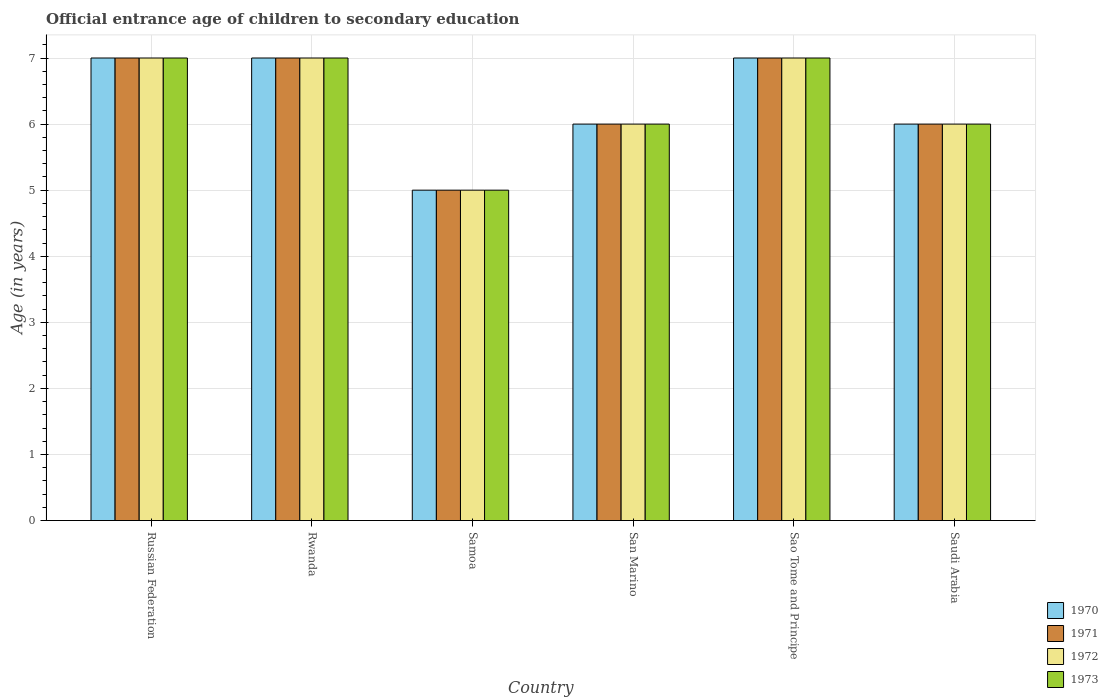What is the label of the 2nd group of bars from the left?
Your answer should be compact. Rwanda. In how many cases, is the number of bars for a given country not equal to the number of legend labels?
Provide a succinct answer. 0. Across all countries, what is the minimum secondary school starting age of children in 1971?
Provide a succinct answer. 5. In which country was the secondary school starting age of children in 1972 maximum?
Give a very brief answer. Russian Federation. In which country was the secondary school starting age of children in 1970 minimum?
Offer a terse response. Samoa. What is the total secondary school starting age of children in 1971 in the graph?
Keep it short and to the point. 38. What is the average secondary school starting age of children in 1972 per country?
Give a very brief answer. 6.33. What is the difference between the secondary school starting age of children of/in 1973 and secondary school starting age of children of/in 1970 in Russian Federation?
Your answer should be compact. 0. In how many countries, is the secondary school starting age of children in 1972 greater than 1.8 years?
Your answer should be compact. 6. What is the ratio of the secondary school starting age of children in 1971 in Sao Tome and Principe to that in Saudi Arabia?
Keep it short and to the point. 1.17. Is the secondary school starting age of children in 1973 in Rwanda less than that in Saudi Arabia?
Keep it short and to the point. No. What is the difference between the highest and the lowest secondary school starting age of children in 1972?
Provide a short and direct response. 2. What does the 1st bar from the right in Sao Tome and Principe represents?
Your answer should be compact. 1973. Is it the case that in every country, the sum of the secondary school starting age of children in 1972 and secondary school starting age of children in 1970 is greater than the secondary school starting age of children in 1971?
Keep it short and to the point. Yes. How many bars are there?
Keep it short and to the point. 24. What is the difference between two consecutive major ticks on the Y-axis?
Keep it short and to the point. 1. Are the values on the major ticks of Y-axis written in scientific E-notation?
Give a very brief answer. No. How are the legend labels stacked?
Your answer should be compact. Vertical. What is the title of the graph?
Give a very brief answer. Official entrance age of children to secondary education. What is the label or title of the X-axis?
Offer a very short reply. Country. What is the label or title of the Y-axis?
Offer a terse response. Age (in years). What is the Age (in years) of 1971 in Russian Federation?
Provide a succinct answer. 7. What is the Age (in years) of 1972 in Russian Federation?
Your answer should be very brief. 7. What is the Age (in years) in 1972 in Rwanda?
Provide a short and direct response. 7. What is the Age (in years) in 1971 in Samoa?
Offer a very short reply. 5. What is the Age (in years) in 1970 in San Marino?
Give a very brief answer. 6. What is the Age (in years) in 1971 in Sao Tome and Principe?
Your answer should be very brief. 7. What is the Age (in years) in 1972 in Sao Tome and Principe?
Your response must be concise. 7. What is the Age (in years) in 1973 in Sao Tome and Principe?
Provide a short and direct response. 7. What is the Age (in years) in 1971 in Saudi Arabia?
Make the answer very short. 6. What is the Age (in years) of 1972 in Saudi Arabia?
Your answer should be compact. 6. Across all countries, what is the maximum Age (in years) of 1970?
Give a very brief answer. 7. Across all countries, what is the maximum Age (in years) in 1971?
Offer a terse response. 7. Across all countries, what is the maximum Age (in years) in 1973?
Provide a short and direct response. 7. Across all countries, what is the minimum Age (in years) in 1970?
Your response must be concise. 5. Across all countries, what is the minimum Age (in years) in 1971?
Ensure brevity in your answer.  5. Across all countries, what is the minimum Age (in years) in 1973?
Offer a terse response. 5. What is the total Age (in years) in 1971 in the graph?
Offer a terse response. 38. What is the total Age (in years) in 1973 in the graph?
Provide a succinct answer. 38. What is the difference between the Age (in years) of 1972 in Russian Federation and that in Samoa?
Your answer should be compact. 2. What is the difference between the Age (in years) in 1973 in Russian Federation and that in Samoa?
Your response must be concise. 2. What is the difference between the Age (in years) in 1971 in Russian Federation and that in San Marino?
Give a very brief answer. 1. What is the difference between the Age (in years) in 1971 in Russian Federation and that in Sao Tome and Principe?
Keep it short and to the point. 0. What is the difference between the Age (in years) in 1972 in Russian Federation and that in Sao Tome and Principe?
Make the answer very short. 0. What is the difference between the Age (in years) in 1973 in Russian Federation and that in Sao Tome and Principe?
Provide a succinct answer. 0. What is the difference between the Age (in years) of 1972 in Russian Federation and that in Saudi Arabia?
Your answer should be compact. 1. What is the difference between the Age (in years) of 1970 in Rwanda and that in Samoa?
Your response must be concise. 2. What is the difference between the Age (in years) in 1970 in Rwanda and that in San Marino?
Ensure brevity in your answer.  1. What is the difference between the Age (in years) of 1972 in Rwanda and that in San Marino?
Your answer should be compact. 1. What is the difference between the Age (in years) in 1970 in Rwanda and that in Sao Tome and Principe?
Keep it short and to the point. 0. What is the difference between the Age (in years) in 1971 in Rwanda and that in Sao Tome and Principe?
Offer a terse response. 0. What is the difference between the Age (in years) of 1971 in Rwanda and that in Saudi Arabia?
Offer a very short reply. 1. What is the difference between the Age (in years) in 1971 in Samoa and that in San Marino?
Make the answer very short. -1. What is the difference between the Age (in years) in 1971 in Samoa and that in Sao Tome and Principe?
Keep it short and to the point. -2. What is the difference between the Age (in years) in 1973 in Samoa and that in Sao Tome and Principe?
Ensure brevity in your answer.  -2. What is the difference between the Age (in years) in 1970 in Samoa and that in Saudi Arabia?
Offer a terse response. -1. What is the difference between the Age (in years) in 1971 in Samoa and that in Saudi Arabia?
Offer a terse response. -1. What is the difference between the Age (in years) in 1973 in Samoa and that in Saudi Arabia?
Offer a very short reply. -1. What is the difference between the Age (in years) in 1970 in San Marino and that in Sao Tome and Principe?
Provide a succinct answer. -1. What is the difference between the Age (in years) of 1973 in San Marino and that in Sao Tome and Principe?
Your answer should be compact. -1. What is the difference between the Age (in years) in 1970 in San Marino and that in Saudi Arabia?
Your answer should be very brief. 0. What is the difference between the Age (in years) of 1971 in San Marino and that in Saudi Arabia?
Ensure brevity in your answer.  0. What is the difference between the Age (in years) of 1972 in San Marino and that in Saudi Arabia?
Keep it short and to the point. 0. What is the difference between the Age (in years) of 1973 in San Marino and that in Saudi Arabia?
Keep it short and to the point. 0. What is the difference between the Age (in years) in 1970 in Sao Tome and Principe and that in Saudi Arabia?
Provide a succinct answer. 1. What is the difference between the Age (in years) of 1972 in Sao Tome and Principe and that in Saudi Arabia?
Provide a short and direct response. 1. What is the difference between the Age (in years) of 1973 in Sao Tome and Principe and that in Saudi Arabia?
Give a very brief answer. 1. What is the difference between the Age (in years) in 1971 in Russian Federation and the Age (in years) in 1973 in Rwanda?
Your answer should be compact. 0. What is the difference between the Age (in years) in 1970 in Russian Federation and the Age (in years) in 1971 in Samoa?
Offer a very short reply. 2. What is the difference between the Age (in years) of 1970 in Russian Federation and the Age (in years) of 1972 in Samoa?
Provide a succinct answer. 2. What is the difference between the Age (in years) of 1970 in Russian Federation and the Age (in years) of 1973 in Samoa?
Make the answer very short. 2. What is the difference between the Age (in years) of 1971 in Russian Federation and the Age (in years) of 1972 in Samoa?
Provide a succinct answer. 2. What is the difference between the Age (in years) in 1971 in Russian Federation and the Age (in years) in 1973 in Samoa?
Give a very brief answer. 2. What is the difference between the Age (in years) of 1972 in Russian Federation and the Age (in years) of 1973 in Samoa?
Keep it short and to the point. 2. What is the difference between the Age (in years) in 1970 in Russian Federation and the Age (in years) in 1972 in San Marino?
Keep it short and to the point. 1. What is the difference between the Age (in years) of 1970 in Russian Federation and the Age (in years) of 1972 in Sao Tome and Principe?
Offer a terse response. 0. What is the difference between the Age (in years) of 1970 in Russian Federation and the Age (in years) of 1973 in Sao Tome and Principe?
Ensure brevity in your answer.  0. What is the difference between the Age (in years) of 1971 in Russian Federation and the Age (in years) of 1972 in Sao Tome and Principe?
Offer a very short reply. 0. What is the difference between the Age (in years) in 1972 in Russian Federation and the Age (in years) in 1973 in Sao Tome and Principe?
Give a very brief answer. 0. What is the difference between the Age (in years) of 1970 in Russian Federation and the Age (in years) of 1971 in Saudi Arabia?
Offer a terse response. 1. What is the difference between the Age (in years) of 1970 in Russian Federation and the Age (in years) of 1972 in Saudi Arabia?
Offer a very short reply. 1. What is the difference between the Age (in years) in 1972 in Russian Federation and the Age (in years) in 1973 in Saudi Arabia?
Give a very brief answer. 1. What is the difference between the Age (in years) of 1970 in Rwanda and the Age (in years) of 1973 in Samoa?
Ensure brevity in your answer.  2. What is the difference between the Age (in years) in 1971 in Rwanda and the Age (in years) in 1972 in Samoa?
Ensure brevity in your answer.  2. What is the difference between the Age (in years) of 1972 in Rwanda and the Age (in years) of 1973 in Samoa?
Offer a very short reply. 2. What is the difference between the Age (in years) in 1970 in Rwanda and the Age (in years) in 1971 in San Marino?
Ensure brevity in your answer.  1. What is the difference between the Age (in years) of 1970 in Rwanda and the Age (in years) of 1972 in San Marino?
Provide a short and direct response. 1. What is the difference between the Age (in years) of 1972 in Rwanda and the Age (in years) of 1973 in San Marino?
Keep it short and to the point. 1. What is the difference between the Age (in years) of 1970 in Rwanda and the Age (in years) of 1971 in Sao Tome and Principe?
Your answer should be very brief. 0. What is the difference between the Age (in years) of 1970 in Rwanda and the Age (in years) of 1973 in Sao Tome and Principe?
Ensure brevity in your answer.  0. What is the difference between the Age (in years) of 1971 in Rwanda and the Age (in years) of 1972 in Sao Tome and Principe?
Give a very brief answer. 0. What is the difference between the Age (in years) in 1970 in Rwanda and the Age (in years) in 1972 in Saudi Arabia?
Give a very brief answer. 1. What is the difference between the Age (in years) in 1970 in Rwanda and the Age (in years) in 1973 in Saudi Arabia?
Your answer should be very brief. 1. What is the difference between the Age (in years) of 1971 in Rwanda and the Age (in years) of 1972 in Saudi Arabia?
Give a very brief answer. 1. What is the difference between the Age (in years) in 1970 in Samoa and the Age (in years) in 1971 in San Marino?
Ensure brevity in your answer.  -1. What is the difference between the Age (in years) of 1970 in Samoa and the Age (in years) of 1972 in San Marino?
Keep it short and to the point. -1. What is the difference between the Age (in years) in 1971 in Samoa and the Age (in years) in 1973 in San Marino?
Provide a succinct answer. -1. What is the difference between the Age (in years) in 1972 in Samoa and the Age (in years) in 1973 in San Marino?
Give a very brief answer. -1. What is the difference between the Age (in years) of 1970 in Samoa and the Age (in years) of 1972 in Sao Tome and Principe?
Give a very brief answer. -2. What is the difference between the Age (in years) in 1970 in Samoa and the Age (in years) in 1973 in Sao Tome and Principe?
Ensure brevity in your answer.  -2. What is the difference between the Age (in years) in 1971 in Samoa and the Age (in years) in 1972 in Sao Tome and Principe?
Ensure brevity in your answer.  -2. What is the difference between the Age (in years) in 1970 in San Marino and the Age (in years) in 1971 in Sao Tome and Principe?
Offer a terse response. -1. What is the difference between the Age (in years) in 1970 in San Marino and the Age (in years) in 1973 in Sao Tome and Principe?
Provide a succinct answer. -1. What is the difference between the Age (in years) of 1971 in San Marino and the Age (in years) of 1972 in Sao Tome and Principe?
Give a very brief answer. -1. What is the difference between the Age (in years) in 1970 in San Marino and the Age (in years) in 1971 in Saudi Arabia?
Ensure brevity in your answer.  0. What is the difference between the Age (in years) of 1970 in San Marino and the Age (in years) of 1972 in Saudi Arabia?
Ensure brevity in your answer.  0. What is the difference between the Age (in years) in 1971 in San Marino and the Age (in years) in 1972 in Saudi Arabia?
Keep it short and to the point. 0. What is the difference between the Age (in years) in 1971 in San Marino and the Age (in years) in 1973 in Saudi Arabia?
Your answer should be very brief. 0. What is the difference between the Age (in years) in 1972 in San Marino and the Age (in years) in 1973 in Saudi Arabia?
Make the answer very short. 0. What is the difference between the Age (in years) of 1970 in Sao Tome and Principe and the Age (in years) of 1971 in Saudi Arabia?
Give a very brief answer. 1. What is the difference between the Age (in years) in 1970 in Sao Tome and Principe and the Age (in years) in 1972 in Saudi Arabia?
Make the answer very short. 1. What is the difference between the Age (in years) in 1971 in Sao Tome and Principe and the Age (in years) in 1973 in Saudi Arabia?
Ensure brevity in your answer.  1. What is the difference between the Age (in years) in 1972 in Sao Tome and Principe and the Age (in years) in 1973 in Saudi Arabia?
Provide a short and direct response. 1. What is the average Age (in years) of 1970 per country?
Ensure brevity in your answer.  6.33. What is the average Age (in years) in 1971 per country?
Your answer should be compact. 6.33. What is the average Age (in years) in 1972 per country?
Your response must be concise. 6.33. What is the average Age (in years) of 1973 per country?
Offer a very short reply. 6.33. What is the difference between the Age (in years) in 1970 and Age (in years) in 1971 in Russian Federation?
Your answer should be compact. 0. What is the difference between the Age (in years) in 1971 and Age (in years) in 1972 in Russian Federation?
Keep it short and to the point. 0. What is the difference between the Age (in years) in 1970 and Age (in years) in 1971 in Rwanda?
Provide a short and direct response. 0. What is the difference between the Age (in years) of 1970 and Age (in years) of 1972 in Rwanda?
Your answer should be compact. 0. What is the difference between the Age (in years) in 1970 and Age (in years) in 1973 in Rwanda?
Give a very brief answer. 0. What is the difference between the Age (in years) in 1971 and Age (in years) in 1973 in Rwanda?
Offer a very short reply. 0. What is the difference between the Age (in years) in 1972 and Age (in years) in 1973 in Rwanda?
Offer a terse response. 0. What is the difference between the Age (in years) in 1970 and Age (in years) in 1971 in Samoa?
Provide a short and direct response. 0. What is the difference between the Age (in years) in 1971 and Age (in years) in 1972 in Samoa?
Provide a succinct answer. 0. What is the difference between the Age (in years) of 1972 and Age (in years) of 1973 in Samoa?
Make the answer very short. 0. What is the difference between the Age (in years) in 1970 and Age (in years) in 1973 in San Marino?
Keep it short and to the point. 0. What is the difference between the Age (in years) in 1971 and Age (in years) in 1972 in San Marino?
Make the answer very short. 0. What is the difference between the Age (in years) of 1971 and Age (in years) of 1973 in San Marino?
Offer a very short reply. 0. What is the difference between the Age (in years) in 1970 and Age (in years) in 1971 in Sao Tome and Principe?
Offer a very short reply. 0. What is the difference between the Age (in years) of 1970 and Age (in years) of 1972 in Sao Tome and Principe?
Ensure brevity in your answer.  0. What is the difference between the Age (in years) in 1971 and Age (in years) in 1972 in Sao Tome and Principe?
Your response must be concise. 0. What is the difference between the Age (in years) of 1971 and Age (in years) of 1973 in Sao Tome and Principe?
Your answer should be compact. 0. What is the difference between the Age (in years) of 1972 and Age (in years) of 1973 in Sao Tome and Principe?
Provide a short and direct response. 0. What is the difference between the Age (in years) of 1970 and Age (in years) of 1971 in Saudi Arabia?
Offer a very short reply. 0. What is the ratio of the Age (in years) of 1971 in Russian Federation to that in Samoa?
Give a very brief answer. 1.4. What is the ratio of the Age (in years) of 1970 in Russian Federation to that in San Marino?
Give a very brief answer. 1.17. What is the ratio of the Age (in years) in 1973 in Russian Federation to that in San Marino?
Give a very brief answer. 1.17. What is the ratio of the Age (in years) in 1970 in Russian Federation to that in Sao Tome and Principe?
Make the answer very short. 1. What is the ratio of the Age (in years) of 1972 in Russian Federation to that in Sao Tome and Principe?
Offer a very short reply. 1. What is the ratio of the Age (in years) of 1970 in Russian Federation to that in Saudi Arabia?
Ensure brevity in your answer.  1.17. What is the ratio of the Age (in years) in 1972 in Russian Federation to that in Saudi Arabia?
Make the answer very short. 1.17. What is the ratio of the Age (in years) in 1973 in Russian Federation to that in Saudi Arabia?
Provide a short and direct response. 1.17. What is the ratio of the Age (in years) of 1971 in Rwanda to that in Samoa?
Your response must be concise. 1.4. What is the ratio of the Age (in years) in 1972 in Rwanda to that in Samoa?
Ensure brevity in your answer.  1.4. What is the ratio of the Age (in years) of 1973 in Rwanda to that in Samoa?
Your response must be concise. 1.4. What is the ratio of the Age (in years) of 1970 in Rwanda to that in San Marino?
Keep it short and to the point. 1.17. What is the ratio of the Age (in years) of 1971 in Rwanda to that in San Marino?
Your answer should be very brief. 1.17. What is the ratio of the Age (in years) of 1972 in Rwanda to that in Sao Tome and Principe?
Offer a very short reply. 1. What is the ratio of the Age (in years) in 1973 in Rwanda to that in Sao Tome and Principe?
Ensure brevity in your answer.  1. What is the ratio of the Age (in years) in 1970 in Rwanda to that in Saudi Arabia?
Provide a short and direct response. 1.17. What is the ratio of the Age (in years) in 1971 in Rwanda to that in Saudi Arabia?
Provide a succinct answer. 1.17. What is the ratio of the Age (in years) of 1973 in Rwanda to that in Saudi Arabia?
Ensure brevity in your answer.  1.17. What is the ratio of the Age (in years) of 1970 in Samoa to that in San Marino?
Offer a terse response. 0.83. What is the ratio of the Age (in years) of 1971 in Samoa to that in San Marino?
Give a very brief answer. 0.83. What is the ratio of the Age (in years) of 1973 in Samoa to that in San Marino?
Your answer should be compact. 0.83. What is the ratio of the Age (in years) in 1971 in Samoa to that in Sao Tome and Principe?
Your answer should be compact. 0.71. What is the ratio of the Age (in years) of 1973 in Samoa to that in Sao Tome and Principe?
Provide a succinct answer. 0.71. What is the ratio of the Age (in years) in 1971 in Samoa to that in Saudi Arabia?
Keep it short and to the point. 0.83. What is the ratio of the Age (in years) of 1972 in Samoa to that in Saudi Arabia?
Your answer should be very brief. 0.83. What is the ratio of the Age (in years) of 1971 in San Marino to that in Sao Tome and Principe?
Your answer should be very brief. 0.86. What is the ratio of the Age (in years) of 1970 in San Marino to that in Saudi Arabia?
Provide a succinct answer. 1. What is the ratio of the Age (in years) of 1973 in San Marino to that in Saudi Arabia?
Offer a very short reply. 1. What is the ratio of the Age (in years) of 1970 in Sao Tome and Principe to that in Saudi Arabia?
Make the answer very short. 1.17. What is the ratio of the Age (in years) in 1971 in Sao Tome and Principe to that in Saudi Arabia?
Your response must be concise. 1.17. What is the ratio of the Age (in years) of 1972 in Sao Tome and Principe to that in Saudi Arabia?
Your answer should be very brief. 1.17. What is the ratio of the Age (in years) of 1973 in Sao Tome and Principe to that in Saudi Arabia?
Ensure brevity in your answer.  1.17. What is the difference between the highest and the second highest Age (in years) of 1971?
Keep it short and to the point. 0. What is the difference between the highest and the second highest Age (in years) of 1972?
Keep it short and to the point. 0. What is the difference between the highest and the second highest Age (in years) in 1973?
Provide a short and direct response. 0. What is the difference between the highest and the lowest Age (in years) in 1972?
Keep it short and to the point. 2. What is the difference between the highest and the lowest Age (in years) of 1973?
Ensure brevity in your answer.  2. 